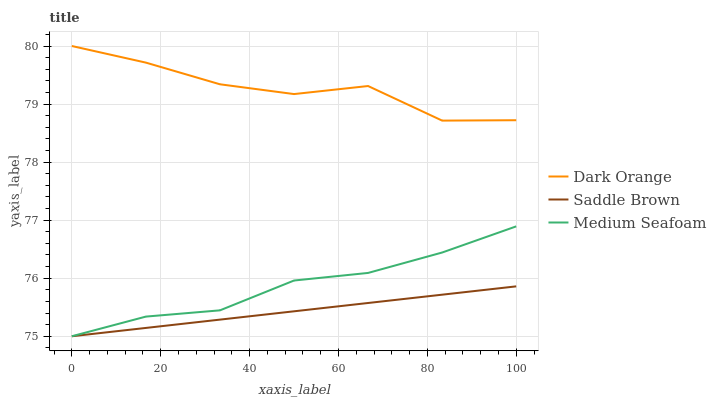Does Saddle Brown have the minimum area under the curve?
Answer yes or no. Yes. Does Dark Orange have the maximum area under the curve?
Answer yes or no. Yes. Does Medium Seafoam have the minimum area under the curve?
Answer yes or no. No. Does Medium Seafoam have the maximum area under the curve?
Answer yes or no. No. Is Saddle Brown the smoothest?
Answer yes or no. Yes. Is Dark Orange the roughest?
Answer yes or no. Yes. Is Medium Seafoam the smoothest?
Answer yes or no. No. Is Medium Seafoam the roughest?
Answer yes or no. No. Does Saddle Brown have the lowest value?
Answer yes or no. Yes. Does Dark Orange have the highest value?
Answer yes or no. Yes. Does Medium Seafoam have the highest value?
Answer yes or no. No. Is Saddle Brown less than Dark Orange?
Answer yes or no. Yes. Is Dark Orange greater than Saddle Brown?
Answer yes or no. Yes. Does Saddle Brown intersect Medium Seafoam?
Answer yes or no. Yes. Is Saddle Brown less than Medium Seafoam?
Answer yes or no. No. Is Saddle Brown greater than Medium Seafoam?
Answer yes or no. No. Does Saddle Brown intersect Dark Orange?
Answer yes or no. No. 